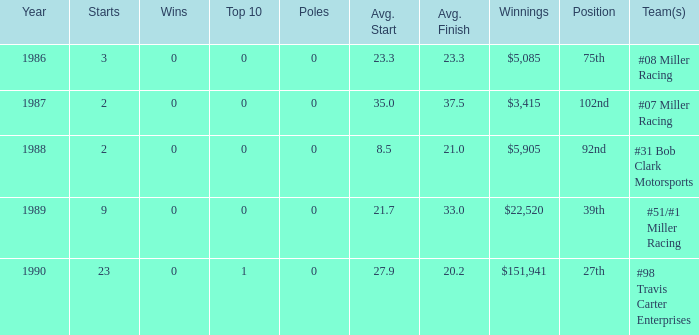Could you parse the entire table? {'header': ['Year', 'Starts', 'Wins', 'Top 10', 'Poles', 'Avg. Start', 'Avg. Finish', 'Winnings', 'Position', 'Team(s)'], 'rows': [['1986', '3', '0', '0', '0', '23.3', '23.3', '$5,085', '75th', '#08 Miller Racing'], ['1987', '2', '0', '0', '0', '35.0', '37.5', '$3,415', '102nd', '#07 Miller Racing'], ['1988', '2', '0', '0', '0', '8.5', '21.0', '$5,905', '92nd', '#31 Bob Clark Motorsports'], ['1989', '9', '0', '0', '0', '21.7', '33.0', '$22,520', '39th', '#51/#1 Miller Racing'], ['1990', '23', '0', '1', '0', '27.9', '20.2', '$151,941', '27th', '#98 Travis Carter Enterprises']]} For which racing teams is the average finishing spot 23.3? #08 Miller Racing. 